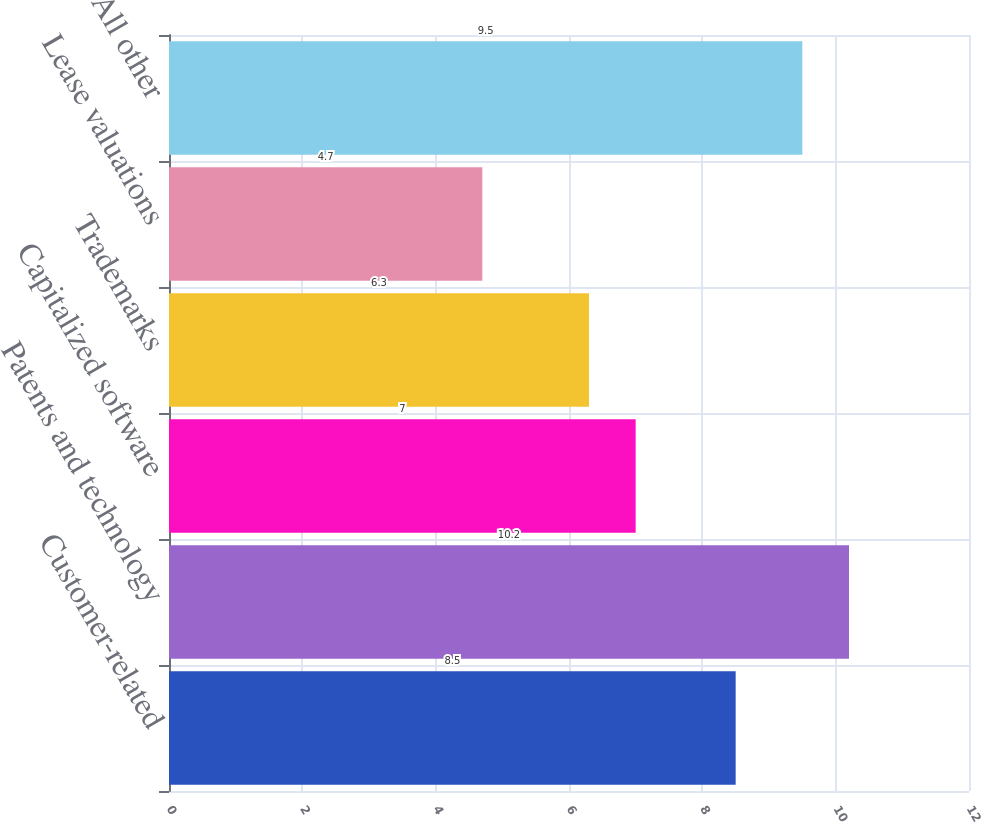<chart> <loc_0><loc_0><loc_500><loc_500><bar_chart><fcel>Customer-related<fcel>Patents and technology<fcel>Capitalized software<fcel>Trademarks<fcel>Lease valuations<fcel>All other<nl><fcel>8.5<fcel>10.2<fcel>7<fcel>6.3<fcel>4.7<fcel>9.5<nl></chart> 